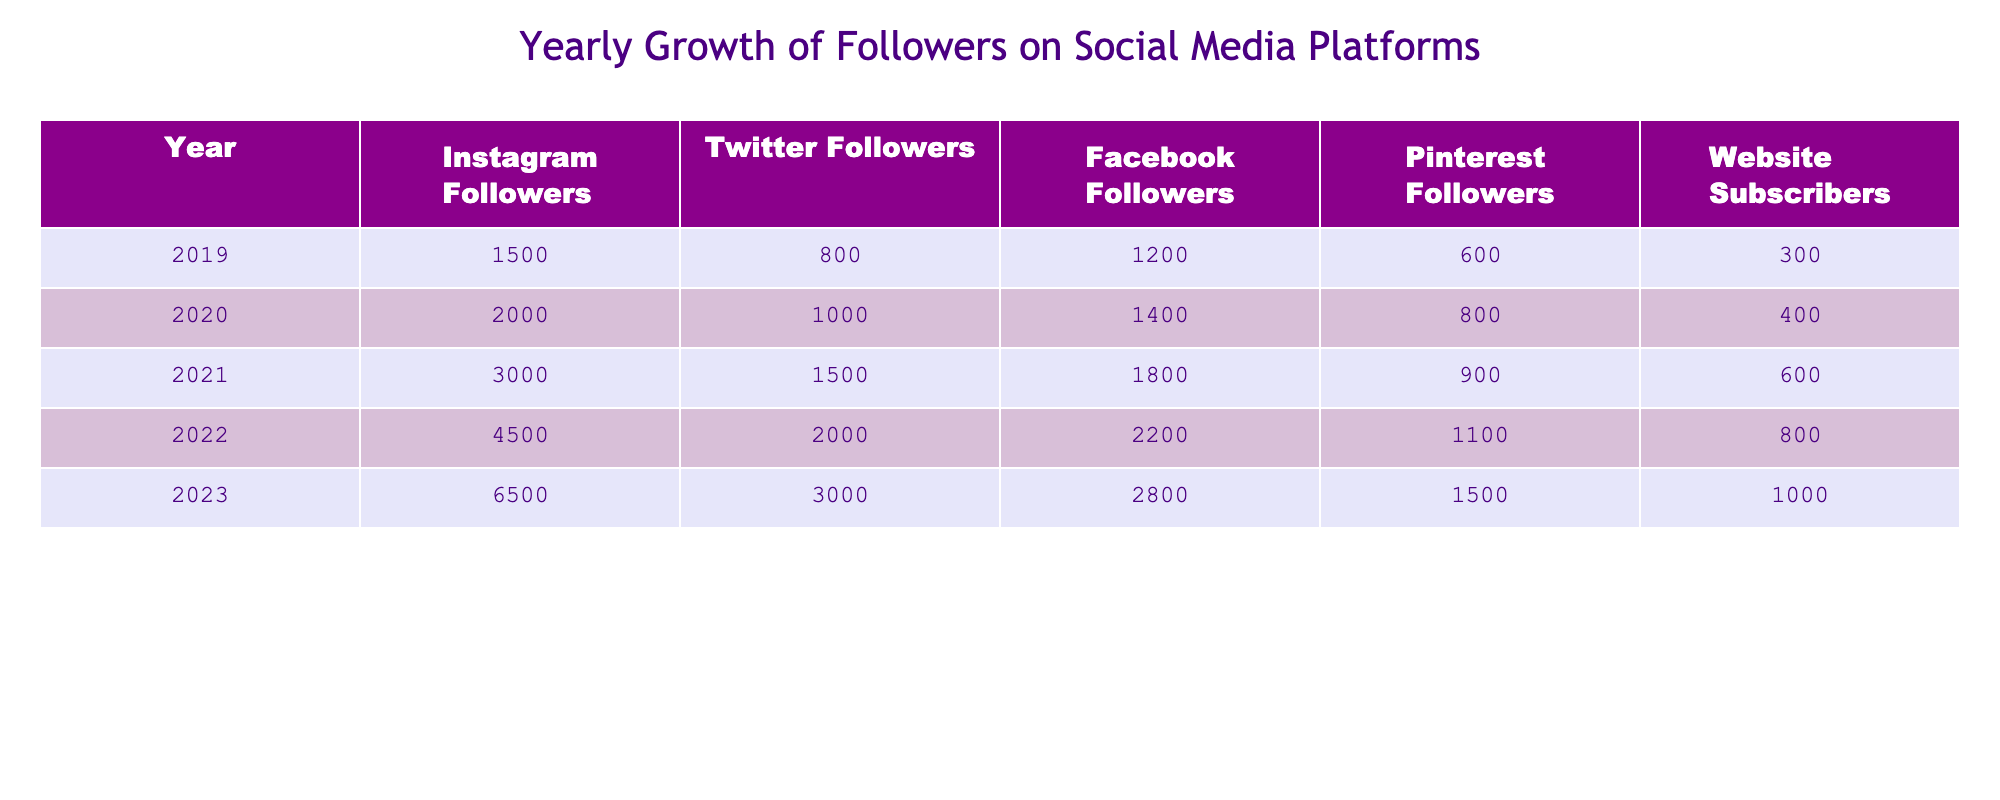What was the number of Instagram followers in 2022? The table shows the number of Instagram followers for each year. In 2022, the value listed is 4500.
Answer: 4500 What is the total growth of Facebook followers from 2019 to 2023? To determine the total growth, subtract the number of Facebook followers in 2019 (1200) from the number in 2023 (2800), which gives 2800 - 1200 = 1600.
Answer: 1600 Is the number of Twitter followers in 2021 greater than the number of Instagram followers in 2020? In 2021, Twitter followers were 1500, and in 2020, Instagram followers were 2000. Since 1500 is less than 2000, the answer is no.
Answer: No What year showed the highest increase in Pinterest followers compared to the previous year? By examining the increments in Pinterest followers year-over-year, the increases are: 200 in 2020, 100 in 2021, 200 in 2022, and 400 in 2023. The highest increase is 400 from 2022 to 2023.
Answer: 2023 What is the average number of website subscribers over the five years presented? First, add the number of website subscribers: 300 + 400 + 600 + 800 + 1000 = 3100. Then divide by the number of years (5): 3100 / 5 = 620.
Answer: 620 Did Twitter followers reach 2000 in any year before 2023? Looking at the values, Twitter followers were 1500 in 2021 and 2000 in 2022. Therefore, they did not reach 2000 before 2023, so the answer is no.
Answer: No What percentage of total followers on Instagram in 2023 compared to all platforms combined that year? The total followers across all platforms in 2023 are: 6500 (Instagram) + 3000 (Twitter) + 2800 (Facebook) + 1500 (Pinterest) + 1000 (Website) = 14800. The percentage of Instagram followers is (6500 / 14800) * 100 = 43.24%.
Answer: 43.24% 